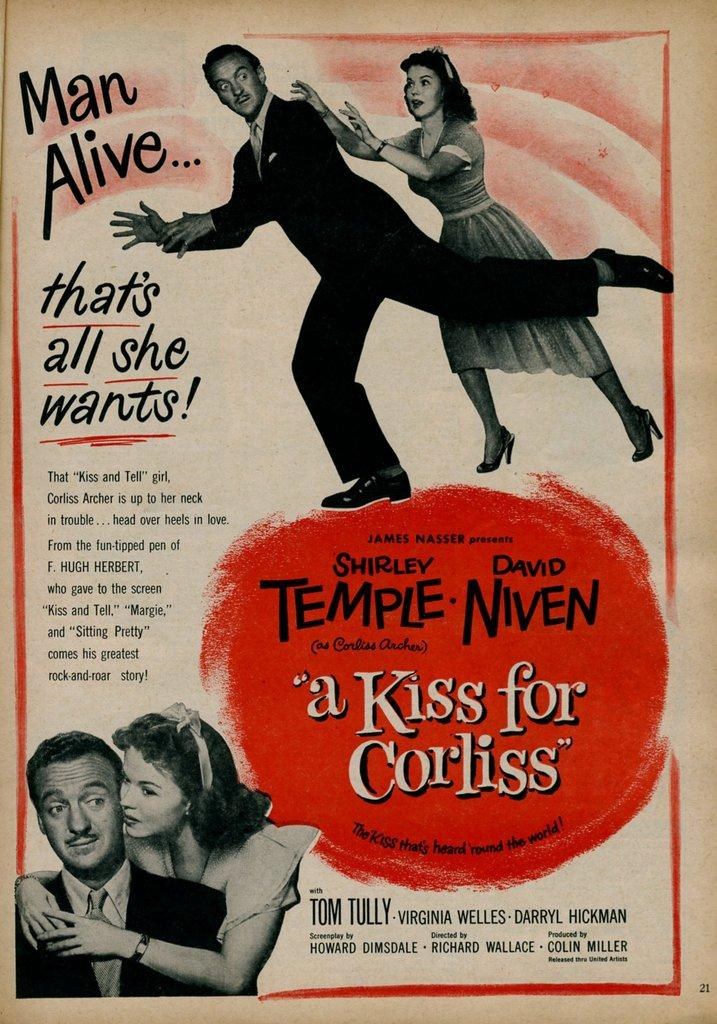<image>
Relay a brief, clear account of the picture shown. a poster for a movie called A Kiss for Corliss 